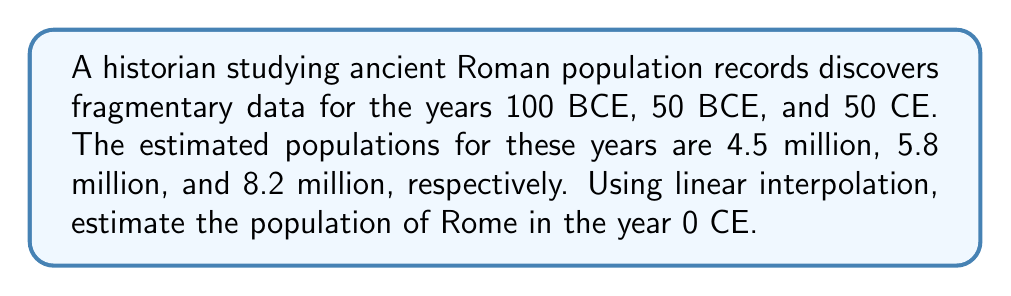Help me with this question. To solve this problem, we'll use linear interpolation between the known data points. Let's follow these steps:

1) First, we need to identify the two data points between which we want to interpolate. The year 0 CE falls between 50 BCE and 50 CE.

2) Let's define our variables:
   $x_1 = -50$ (50 BCE)
   $y_1 = 5.8$ million (population at 50 BCE)
   $x_2 = 50$ (50 CE)
   $y_2 = 8.2$ million (population at 50 CE)
   $x = 0$ (the year we want to estimate)
   $y = $ the population we're trying to find

3) The linear interpolation formula is:

   $$ y = y_1 + \frac{(x - x_1)(y_2 - y_1)}{x_2 - x_1} $$

4) Let's substitute our values:

   $$ y = 5.8 + \frac{(0 - (-50))(8.2 - 5.8)}{50 - (-50)} $$

5) Simplify:
   $$ y = 5.8 + \frac{50(2.4)}{100} = 5.8 + \frac{120}{100} = 5.8 + 1.2 = 7 $$

Therefore, the estimated population of Rome in 0 CE is 7 million.
Answer: 7 million 